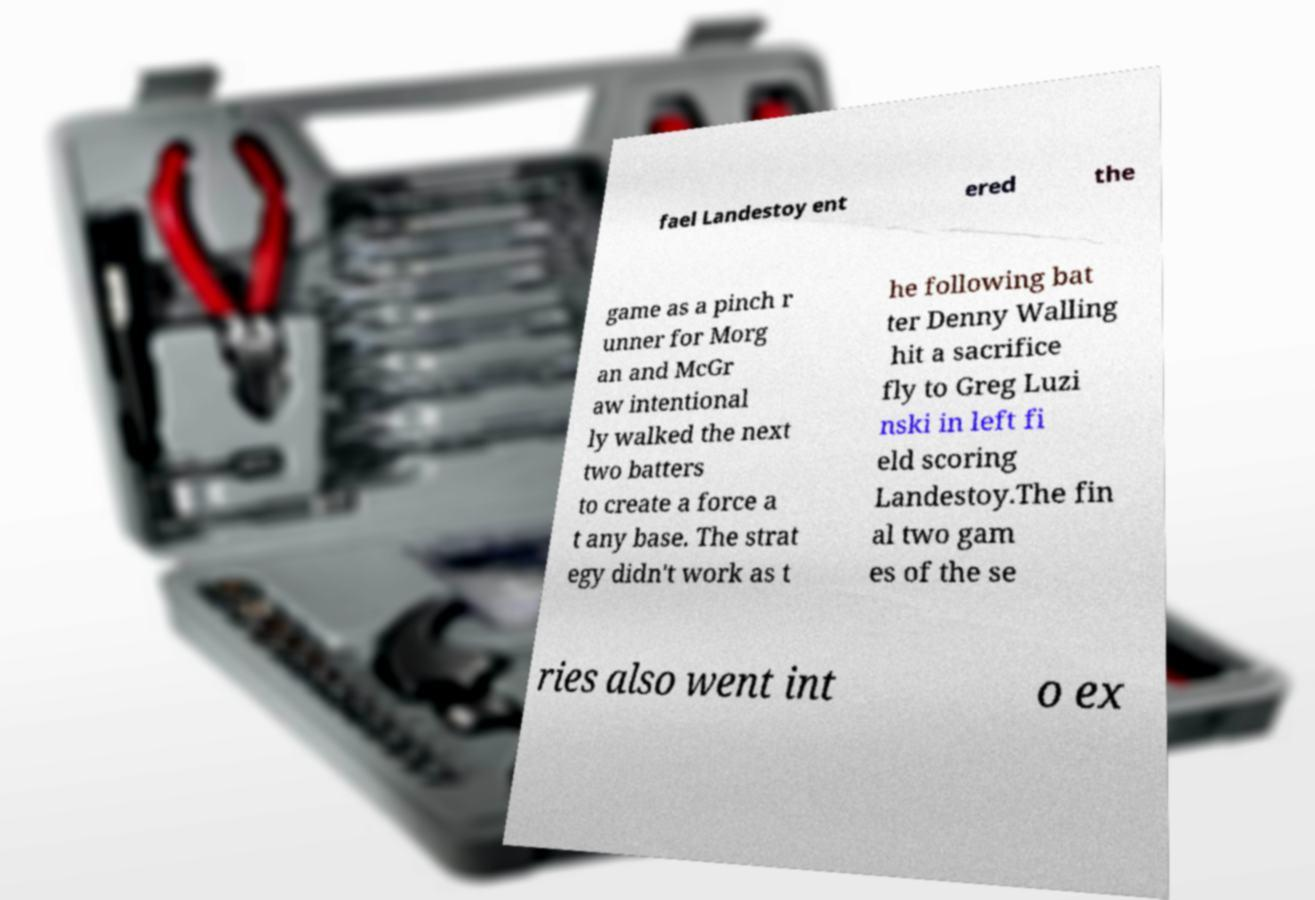Could you assist in decoding the text presented in this image and type it out clearly? fael Landestoy ent ered the game as a pinch r unner for Morg an and McGr aw intentional ly walked the next two batters to create a force a t any base. The strat egy didn't work as t he following bat ter Denny Walling hit a sacrifice fly to Greg Luzi nski in left fi eld scoring Landestoy.The fin al two gam es of the se ries also went int o ex 